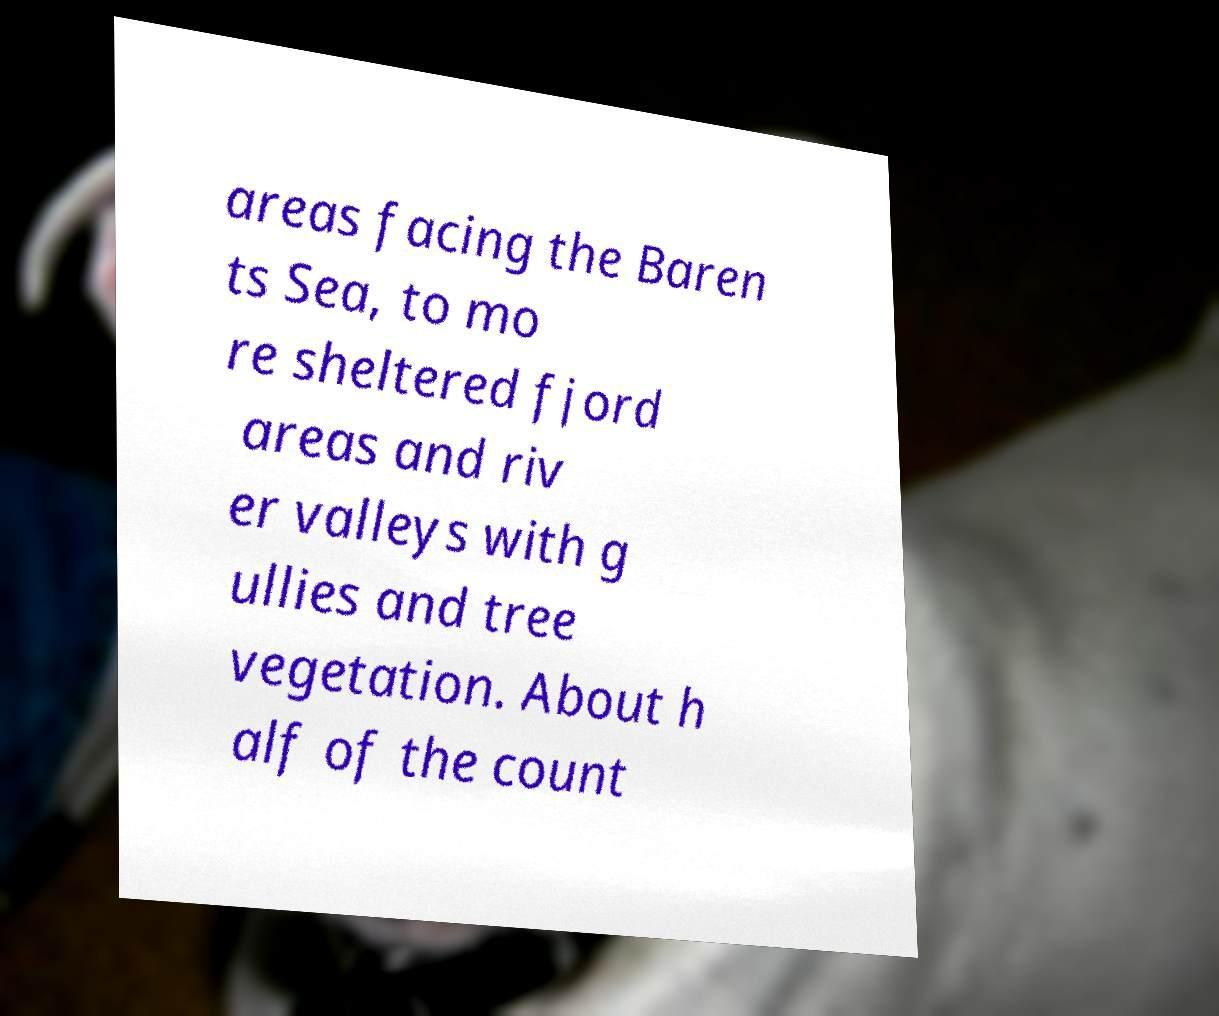I need the written content from this picture converted into text. Can you do that? areas facing the Baren ts Sea, to mo re sheltered fjord areas and riv er valleys with g ullies and tree vegetation. About h alf of the count 